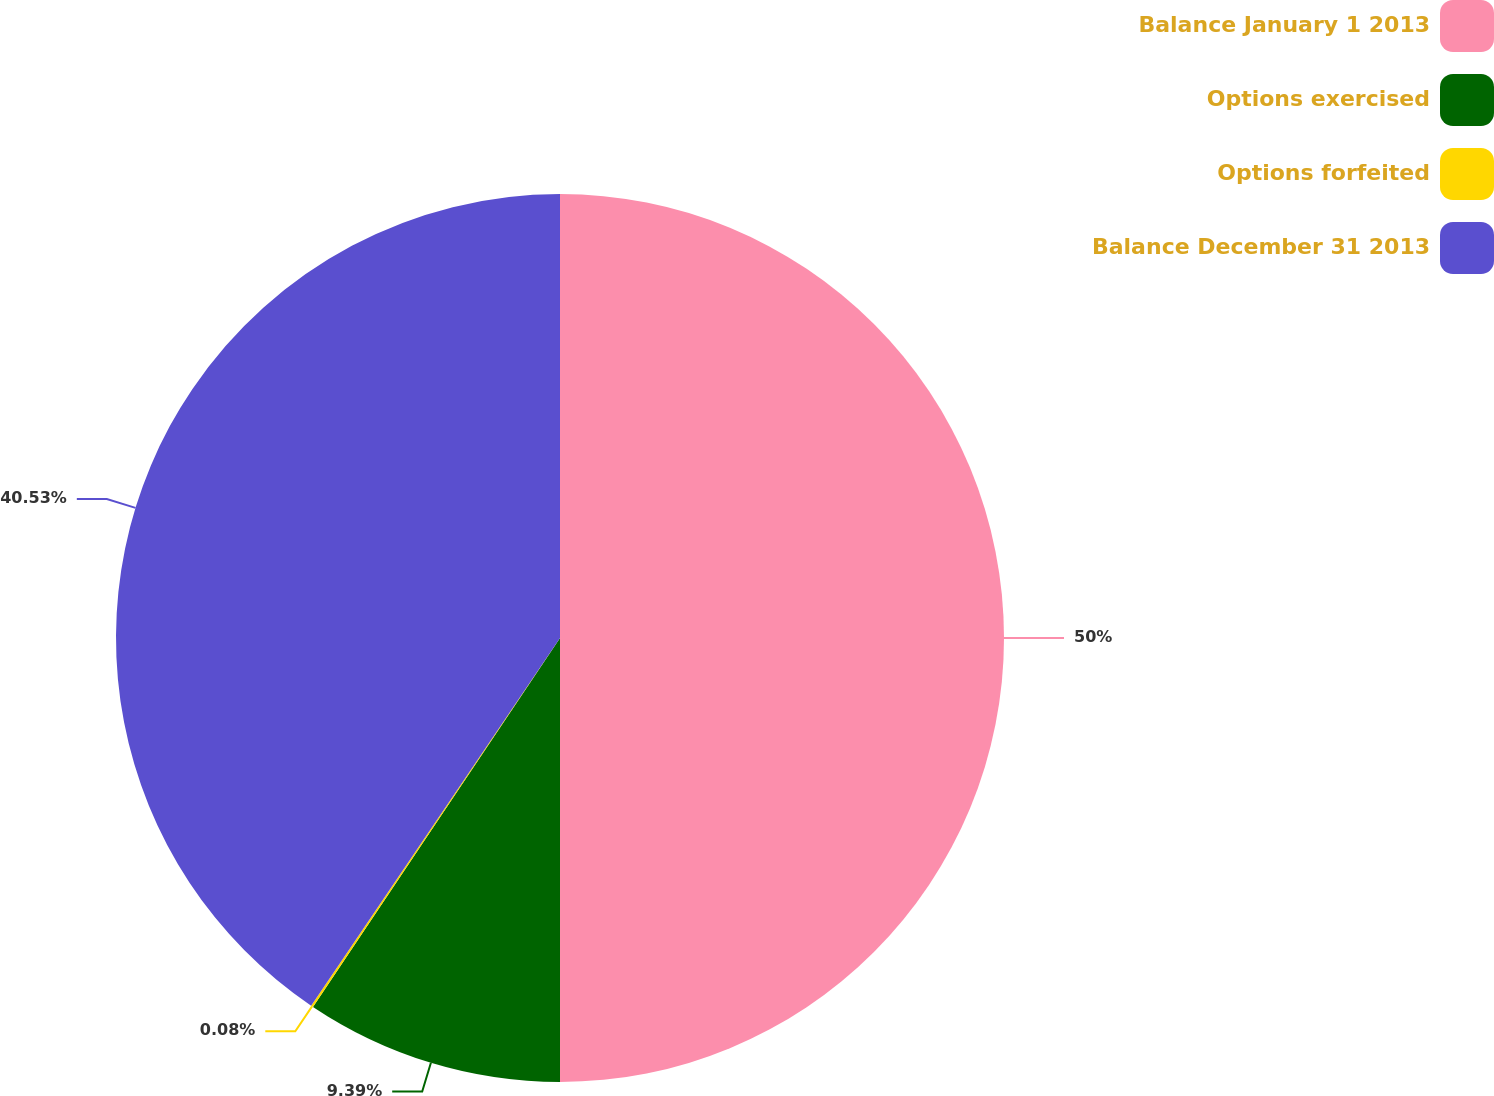Convert chart to OTSL. <chart><loc_0><loc_0><loc_500><loc_500><pie_chart><fcel>Balance January 1 2013<fcel>Options exercised<fcel>Options forfeited<fcel>Balance December 31 2013<nl><fcel>50.0%<fcel>9.39%<fcel>0.08%<fcel>40.53%<nl></chart> 